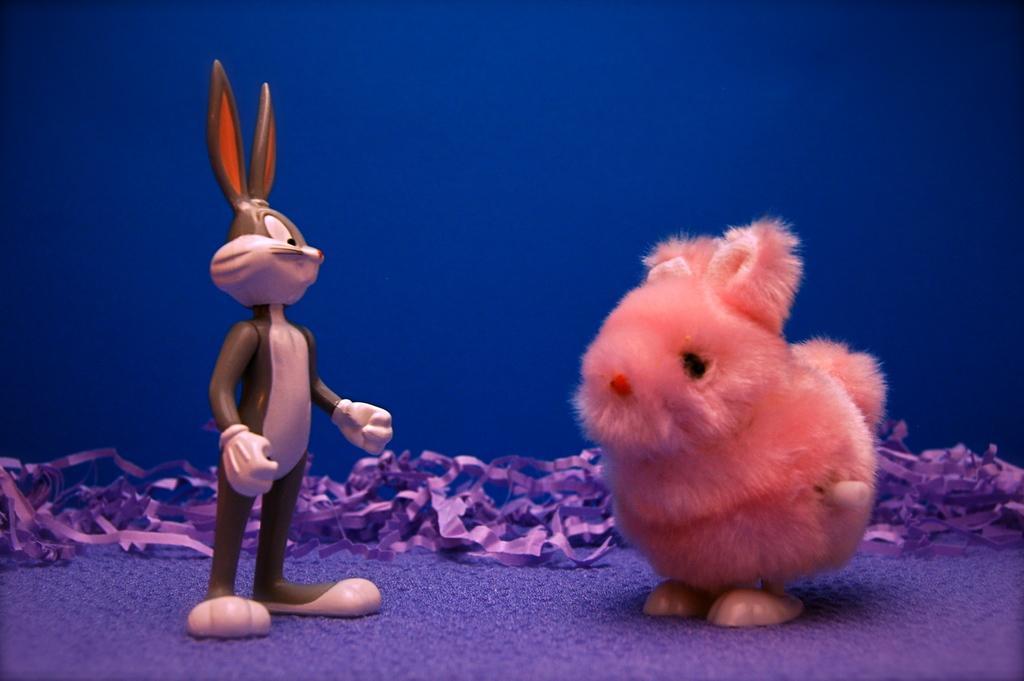How would you summarize this image in a sentence or two? In the image there is bugs bunny and a rabbit on the floor and behind there are ribbons. 